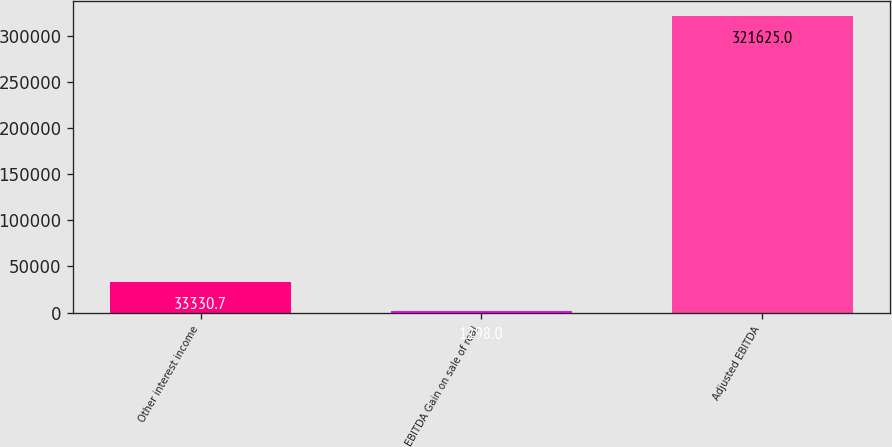Convert chart to OTSL. <chart><loc_0><loc_0><loc_500><loc_500><bar_chart><fcel>Other interest income<fcel>EBITDA Gain on sale of real<fcel>Adjusted EBITDA<nl><fcel>33330.7<fcel>1298<fcel>321625<nl></chart> 